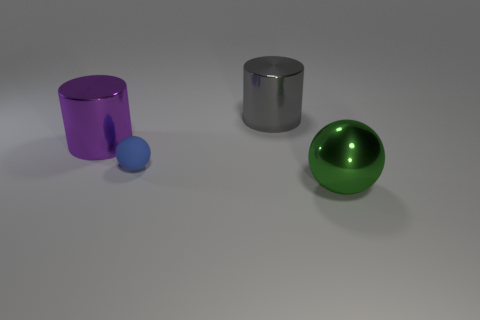Add 4 big blue metal blocks. How many objects exist? 8 Subtract all large red metal objects. Subtract all large cylinders. How many objects are left? 2 Add 4 large shiny cylinders. How many large shiny cylinders are left? 6 Add 2 small blue balls. How many small blue balls exist? 3 Subtract 1 green balls. How many objects are left? 3 